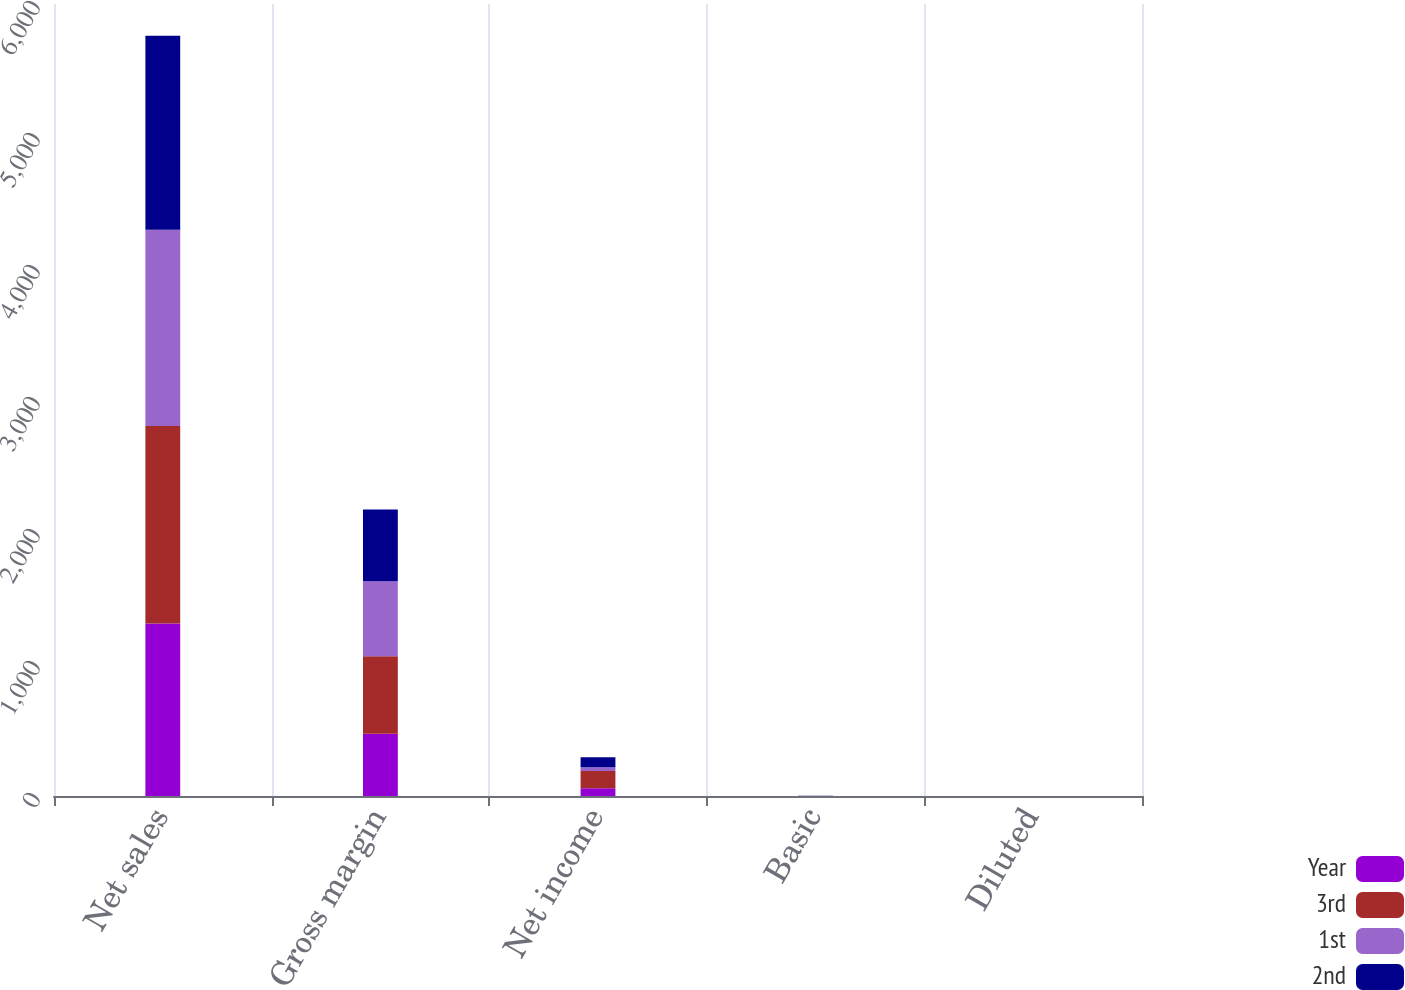Convert chart. <chart><loc_0><loc_0><loc_500><loc_500><stacked_bar_chart><ecel><fcel>Net sales<fcel>Gross margin<fcel>Net income<fcel>Basic<fcel>Diluted<nl><fcel>Year<fcel>1306.4<fcel>471.7<fcel>58.4<fcel>0.21<fcel>0.19<nl><fcel>3rd<fcel>1496.2<fcel>587.3<fcel>130.4<fcel>0.46<fcel>0.41<nl><fcel>1st<fcel>1487.3<fcel>567.1<fcel>28.3<fcel>0.1<fcel>0.09<nl><fcel>2nd<fcel>1469.3<fcel>544.7<fcel>75.7<fcel>0.26<fcel>0.25<nl></chart> 